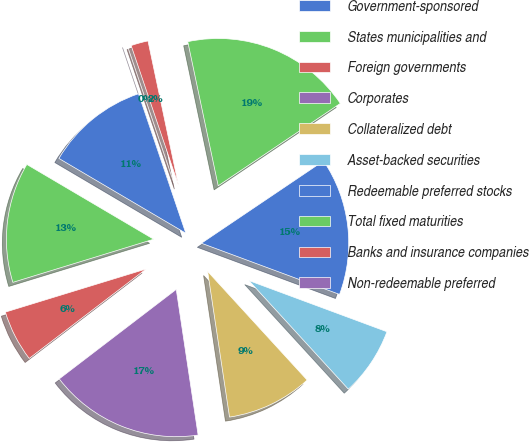Convert chart. <chart><loc_0><loc_0><loc_500><loc_500><pie_chart><fcel>Government-sponsored<fcel>States municipalities and<fcel>Foreign governments<fcel>Corporates<fcel>Collateralized debt<fcel>Asset-backed securities<fcel>Redeemable preferred stocks<fcel>Total fixed maturities<fcel>Banks and insurance companies<fcel>Non-redeemable preferred<nl><fcel>11.32%<fcel>13.21%<fcel>5.66%<fcel>16.98%<fcel>9.43%<fcel>7.55%<fcel>15.09%<fcel>18.87%<fcel>1.89%<fcel>0.0%<nl></chart> 